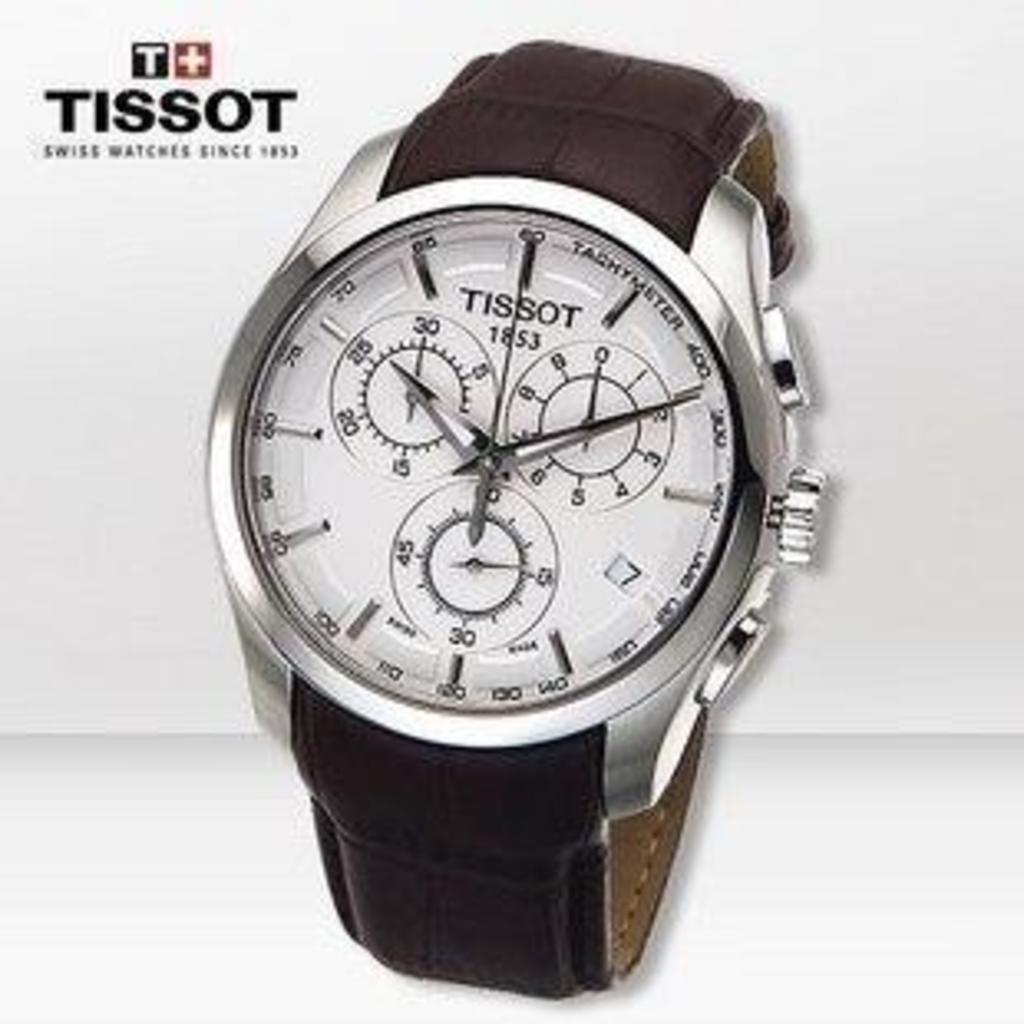<image>
Describe the image concisely. An advertisement poster with a TISSOT watch pictured with a silver face and black wrist band. 